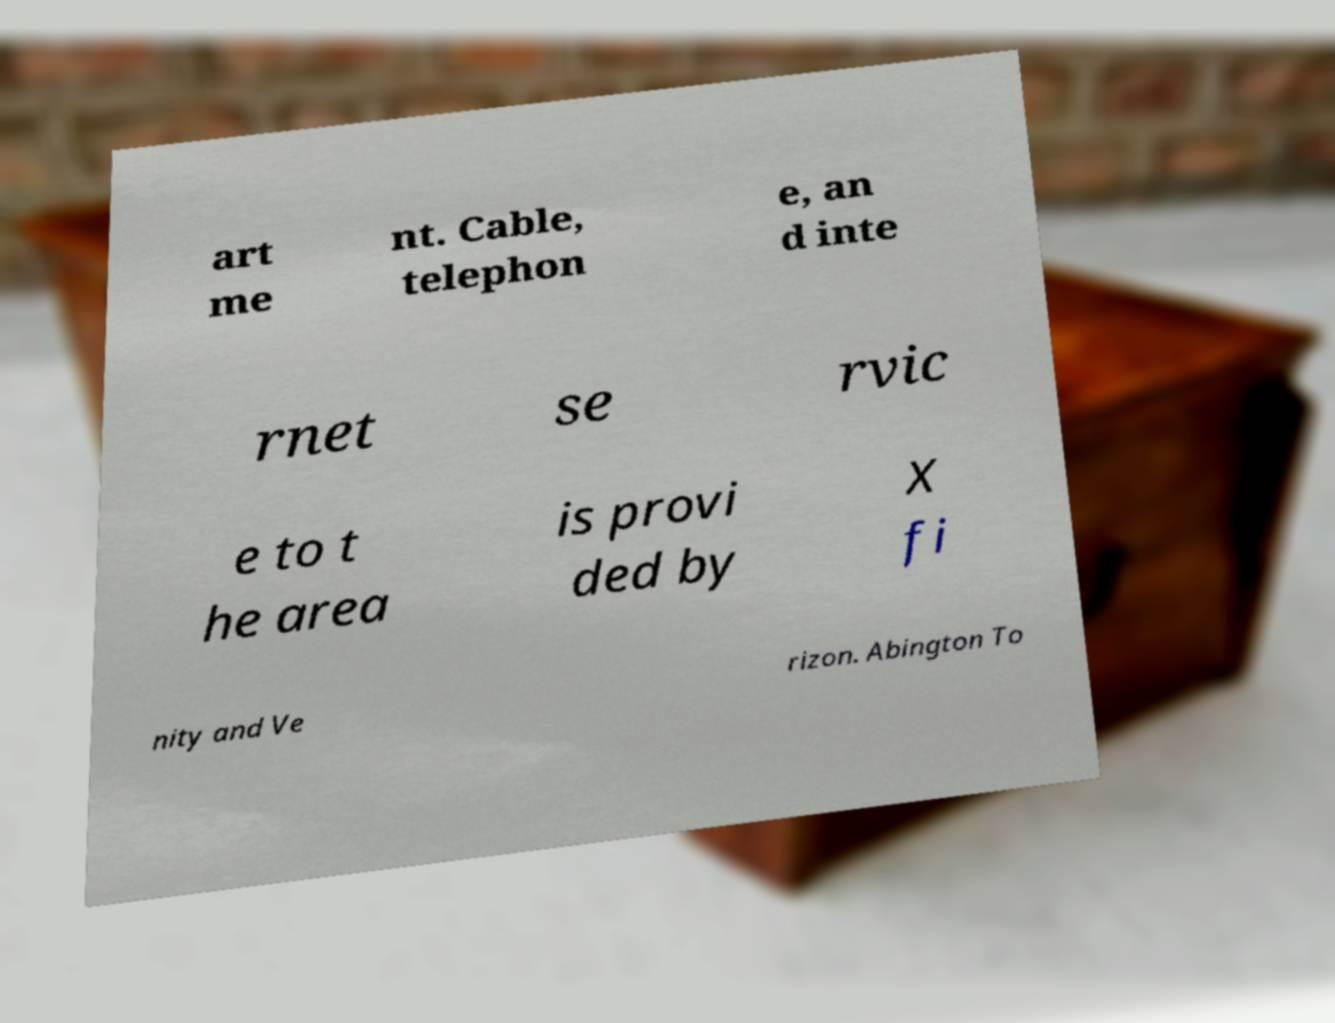Could you extract and type out the text from this image? art me nt. Cable, telephon e, an d inte rnet se rvic e to t he area is provi ded by X fi nity and Ve rizon. Abington To 